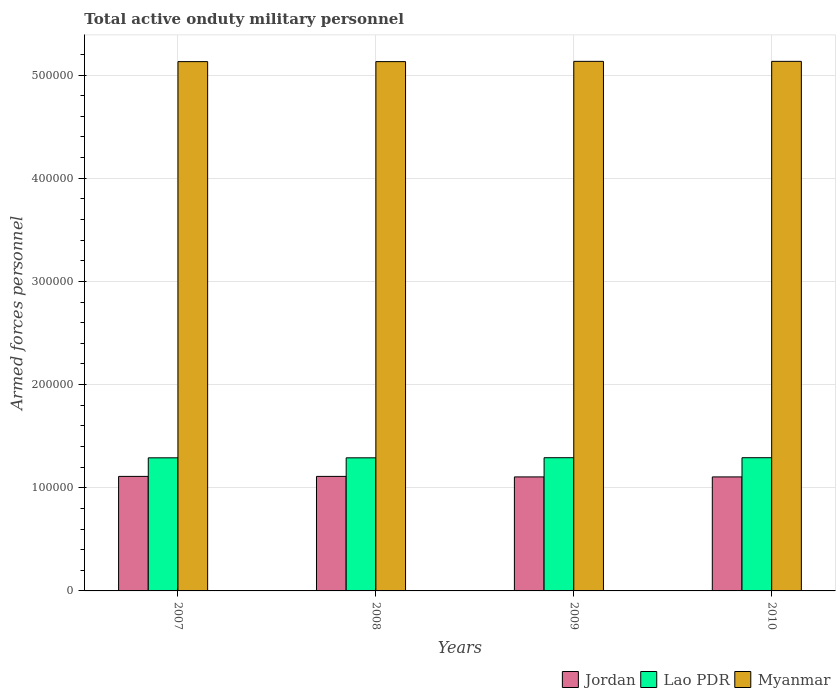How many different coloured bars are there?
Provide a short and direct response. 3. Are the number of bars on each tick of the X-axis equal?
Your response must be concise. Yes. How many bars are there on the 4th tick from the right?
Your answer should be very brief. 3. In how many cases, is the number of bars for a given year not equal to the number of legend labels?
Give a very brief answer. 0. What is the number of armed forces personnel in Myanmar in 2010?
Ensure brevity in your answer.  5.13e+05. Across all years, what is the maximum number of armed forces personnel in Lao PDR?
Make the answer very short. 1.29e+05. Across all years, what is the minimum number of armed forces personnel in Lao PDR?
Make the answer very short. 1.29e+05. What is the total number of armed forces personnel in Jordan in the graph?
Provide a short and direct response. 4.43e+05. What is the difference between the number of armed forces personnel in Lao PDR in 2007 and that in 2009?
Ensure brevity in your answer.  -100. What is the difference between the number of armed forces personnel in Jordan in 2010 and the number of armed forces personnel in Lao PDR in 2009?
Provide a succinct answer. -1.86e+04. What is the average number of armed forces personnel in Lao PDR per year?
Your answer should be compact. 1.29e+05. In the year 2009, what is the difference between the number of armed forces personnel in Myanmar and number of armed forces personnel in Lao PDR?
Provide a short and direct response. 3.84e+05. In how many years, is the number of armed forces personnel in Myanmar greater than 20000?
Your response must be concise. 4. What is the ratio of the number of armed forces personnel in Lao PDR in 2008 to that in 2010?
Offer a very short reply. 1. Is the difference between the number of armed forces personnel in Myanmar in 2009 and 2010 greater than the difference between the number of armed forces personnel in Lao PDR in 2009 and 2010?
Offer a very short reply. No. What is the difference between the highest and the second highest number of armed forces personnel in Lao PDR?
Ensure brevity in your answer.  0. What is the difference between the highest and the lowest number of armed forces personnel in Myanmar?
Your response must be concise. 250. In how many years, is the number of armed forces personnel in Myanmar greater than the average number of armed forces personnel in Myanmar taken over all years?
Provide a succinct answer. 2. Is the sum of the number of armed forces personnel in Myanmar in 2008 and 2010 greater than the maximum number of armed forces personnel in Lao PDR across all years?
Your response must be concise. Yes. What does the 2nd bar from the left in 2007 represents?
Give a very brief answer. Lao PDR. What does the 3rd bar from the right in 2009 represents?
Keep it short and to the point. Jordan. Are all the bars in the graph horizontal?
Give a very brief answer. No. Are the values on the major ticks of Y-axis written in scientific E-notation?
Provide a succinct answer. No. Does the graph contain any zero values?
Make the answer very short. No. Does the graph contain grids?
Your response must be concise. Yes. How many legend labels are there?
Your response must be concise. 3. What is the title of the graph?
Keep it short and to the point. Total active onduty military personnel. Does "Virgin Islands" appear as one of the legend labels in the graph?
Your answer should be very brief. No. What is the label or title of the X-axis?
Your response must be concise. Years. What is the label or title of the Y-axis?
Make the answer very short. Armed forces personnel. What is the Armed forces personnel in Jordan in 2007?
Offer a terse response. 1.11e+05. What is the Armed forces personnel of Lao PDR in 2007?
Keep it short and to the point. 1.29e+05. What is the Armed forces personnel of Myanmar in 2007?
Offer a terse response. 5.13e+05. What is the Armed forces personnel in Jordan in 2008?
Provide a succinct answer. 1.11e+05. What is the Armed forces personnel in Lao PDR in 2008?
Your response must be concise. 1.29e+05. What is the Armed forces personnel in Myanmar in 2008?
Ensure brevity in your answer.  5.13e+05. What is the Armed forces personnel of Jordan in 2009?
Ensure brevity in your answer.  1.10e+05. What is the Armed forces personnel in Lao PDR in 2009?
Your answer should be compact. 1.29e+05. What is the Armed forces personnel of Myanmar in 2009?
Keep it short and to the point. 5.13e+05. What is the Armed forces personnel in Jordan in 2010?
Your response must be concise. 1.10e+05. What is the Armed forces personnel in Lao PDR in 2010?
Provide a short and direct response. 1.29e+05. What is the Armed forces personnel in Myanmar in 2010?
Provide a short and direct response. 5.13e+05. Across all years, what is the maximum Armed forces personnel in Jordan?
Your answer should be compact. 1.11e+05. Across all years, what is the maximum Armed forces personnel of Lao PDR?
Your response must be concise. 1.29e+05. Across all years, what is the maximum Armed forces personnel of Myanmar?
Your answer should be compact. 5.13e+05. Across all years, what is the minimum Armed forces personnel in Jordan?
Provide a succinct answer. 1.10e+05. Across all years, what is the minimum Armed forces personnel in Lao PDR?
Make the answer very short. 1.29e+05. Across all years, what is the minimum Armed forces personnel in Myanmar?
Make the answer very short. 5.13e+05. What is the total Armed forces personnel in Jordan in the graph?
Provide a short and direct response. 4.43e+05. What is the total Armed forces personnel of Lao PDR in the graph?
Keep it short and to the point. 5.16e+05. What is the total Armed forces personnel in Myanmar in the graph?
Provide a succinct answer. 2.05e+06. What is the difference between the Armed forces personnel of Jordan in 2007 and that in 2008?
Ensure brevity in your answer.  0. What is the difference between the Armed forces personnel of Myanmar in 2007 and that in 2008?
Offer a very short reply. 0. What is the difference between the Armed forces personnel in Lao PDR in 2007 and that in 2009?
Your response must be concise. -100. What is the difference between the Armed forces personnel of Myanmar in 2007 and that in 2009?
Offer a very short reply. -250. What is the difference between the Armed forces personnel in Jordan in 2007 and that in 2010?
Offer a very short reply. 500. What is the difference between the Armed forces personnel in Lao PDR in 2007 and that in 2010?
Your answer should be compact. -100. What is the difference between the Armed forces personnel of Myanmar in 2007 and that in 2010?
Ensure brevity in your answer.  -250. What is the difference between the Armed forces personnel in Lao PDR in 2008 and that in 2009?
Your response must be concise. -100. What is the difference between the Armed forces personnel in Myanmar in 2008 and that in 2009?
Provide a short and direct response. -250. What is the difference between the Armed forces personnel of Lao PDR in 2008 and that in 2010?
Provide a short and direct response. -100. What is the difference between the Armed forces personnel in Myanmar in 2008 and that in 2010?
Make the answer very short. -250. What is the difference between the Armed forces personnel in Myanmar in 2009 and that in 2010?
Give a very brief answer. 0. What is the difference between the Armed forces personnel in Jordan in 2007 and the Armed forces personnel in Lao PDR in 2008?
Your answer should be very brief. -1.80e+04. What is the difference between the Armed forces personnel in Jordan in 2007 and the Armed forces personnel in Myanmar in 2008?
Keep it short and to the point. -4.02e+05. What is the difference between the Armed forces personnel of Lao PDR in 2007 and the Armed forces personnel of Myanmar in 2008?
Provide a short and direct response. -3.84e+05. What is the difference between the Armed forces personnel in Jordan in 2007 and the Armed forces personnel in Lao PDR in 2009?
Offer a terse response. -1.81e+04. What is the difference between the Armed forces personnel in Jordan in 2007 and the Armed forces personnel in Myanmar in 2009?
Make the answer very short. -4.02e+05. What is the difference between the Armed forces personnel of Lao PDR in 2007 and the Armed forces personnel of Myanmar in 2009?
Ensure brevity in your answer.  -3.84e+05. What is the difference between the Armed forces personnel of Jordan in 2007 and the Armed forces personnel of Lao PDR in 2010?
Make the answer very short. -1.81e+04. What is the difference between the Armed forces personnel in Jordan in 2007 and the Armed forces personnel in Myanmar in 2010?
Offer a very short reply. -4.02e+05. What is the difference between the Armed forces personnel in Lao PDR in 2007 and the Armed forces personnel in Myanmar in 2010?
Your response must be concise. -3.84e+05. What is the difference between the Armed forces personnel in Jordan in 2008 and the Armed forces personnel in Lao PDR in 2009?
Your response must be concise. -1.81e+04. What is the difference between the Armed forces personnel in Jordan in 2008 and the Armed forces personnel in Myanmar in 2009?
Your response must be concise. -4.02e+05. What is the difference between the Armed forces personnel of Lao PDR in 2008 and the Armed forces personnel of Myanmar in 2009?
Make the answer very short. -3.84e+05. What is the difference between the Armed forces personnel of Jordan in 2008 and the Armed forces personnel of Lao PDR in 2010?
Provide a succinct answer. -1.81e+04. What is the difference between the Armed forces personnel of Jordan in 2008 and the Armed forces personnel of Myanmar in 2010?
Your answer should be compact. -4.02e+05. What is the difference between the Armed forces personnel of Lao PDR in 2008 and the Armed forces personnel of Myanmar in 2010?
Your answer should be compact. -3.84e+05. What is the difference between the Armed forces personnel of Jordan in 2009 and the Armed forces personnel of Lao PDR in 2010?
Keep it short and to the point. -1.86e+04. What is the difference between the Armed forces personnel of Jordan in 2009 and the Armed forces personnel of Myanmar in 2010?
Provide a succinct answer. -4.03e+05. What is the difference between the Armed forces personnel of Lao PDR in 2009 and the Armed forces personnel of Myanmar in 2010?
Your response must be concise. -3.84e+05. What is the average Armed forces personnel of Jordan per year?
Offer a very short reply. 1.11e+05. What is the average Armed forces personnel in Lao PDR per year?
Make the answer very short. 1.29e+05. What is the average Armed forces personnel of Myanmar per year?
Your answer should be very brief. 5.13e+05. In the year 2007, what is the difference between the Armed forces personnel in Jordan and Armed forces personnel in Lao PDR?
Your response must be concise. -1.80e+04. In the year 2007, what is the difference between the Armed forces personnel in Jordan and Armed forces personnel in Myanmar?
Provide a short and direct response. -4.02e+05. In the year 2007, what is the difference between the Armed forces personnel in Lao PDR and Armed forces personnel in Myanmar?
Keep it short and to the point. -3.84e+05. In the year 2008, what is the difference between the Armed forces personnel in Jordan and Armed forces personnel in Lao PDR?
Your response must be concise. -1.80e+04. In the year 2008, what is the difference between the Armed forces personnel in Jordan and Armed forces personnel in Myanmar?
Your answer should be very brief. -4.02e+05. In the year 2008, what is the difference between the Armed forces personnel in Lao PDR and Armed forces personnel in Myanmar?
Give a very brief answer. -3.84e+05. In the year 2009, what is the difference between the Armed forces personnel of Jordan and Armed forces personnel of Lao PDR?
Make the answer very short. -1.86e+04. In the year 2009, what is the difference between the Armed forces personnel in Jordan and Armed forces personnel in Myanmar?
Give a very brief answer. -4.03e+05. In the year 2009, what is the difference between the Armed forces personnel of Lao PDR and Armed forces personnel of Myanmar?
Make the answer very short. -3.84e+05. In the year 2010, what is the difference between the Armed forces personnel in Jordan and Armed forces personnel in Lao PDR?
Keep it short and to the point. -1.86e+04. In the year 2010, what is the difference between the Armed forces personnel in Jordan and Armed forces personnel in Myanmar?
Your response must be concise. -4.03e+05. In the year 2010, what is the difference between the Armed forces personnel in Lao PDR and Armed forces personnel in Myanmar?
Ensure brevity in your answer.  -3.84e+05. What is the ratio of the Armed forces personnel of Lao PDR in 2007 to that in 2008?
Provide a succinct answer. 1. What is the ratio of the Armed forces personnel in Jordan in 2007 to that in 2009?
Provide a short and direct response. 1. What is the ratio of the Armed forces personnel of Lao PDR in 2007 to that in 2009?
Your answer should be compact. 1. What is the ratio of the Armed forces personnel of Lao PDR in 2007 to that in 2010?
Provide a short and direct response. 1. What is the ratio of the Armed forces personnel in Jordan in 2008 to that in 2010?
Provide a succinct answer. 1. What is the ratio of the Armed forces personnel in Lao PDR in 2008 to that in 2010?
Provide a succinct answer. 1. What is the ratio of the Armed forces personnel of Lao PDR in 2009 to that in 2010?
Keep it short and to the point. 1. What is the difference between the highest and the second highest Armed forces personnel of Jordan?
Your answer should be very brief. 0. What is the difference between the highest and the second highest Armed forces personnel in Lao PDR?
Keep it short and to the point. 0. What is the difference between the highest and the lowest Armed forces personnel of Myanmar?
Provide a succinct answer. 250. 